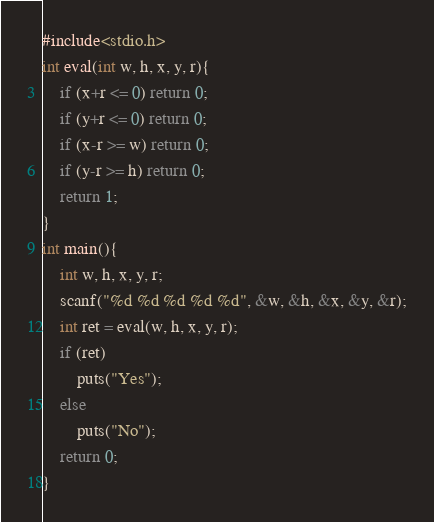Convert code to text. <code><loc_0><loc_0><loc_500><loc_500><_C_>#include<stdio.h>
int eval(int w, h, x, y, r){
    if (x+r <= 0) return 0;
    if (y+r <= 0) return 0;
    if (x-r >= w) return 0;
    if (y-r >= h) return 0;
    return 1;
}
int main(){
    int w, h, x, y, r;
    scanf("%d %d %d %d %d", &w, &h, &x, &y, &r);
    int ret = eval(w, h, x, y, r);
    if (ret)
        puts("Yes");
    else
        puts("No");
    return 0;
}</code> 